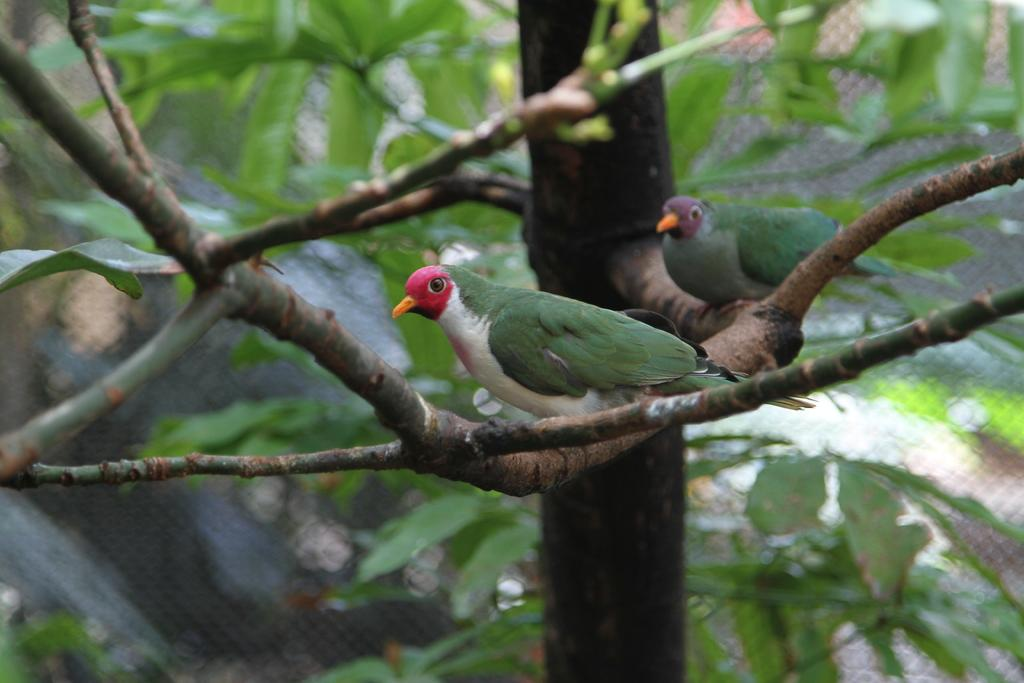What is the main subject in the center of the image? There are trees in the center of the image. Are there any animals present in the image? Yes, there are two birds on the branches of the trees. Can you describe the appearance of the birds? The birds are in different colors. How many brothers are participating in the protest shown in the image? There is no protest or brothers present in the image; it features trees and birds. 